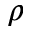Convert formula to latex. <formula><loc_0><loc_0><loc_500><loc_500>\rho</formula> 